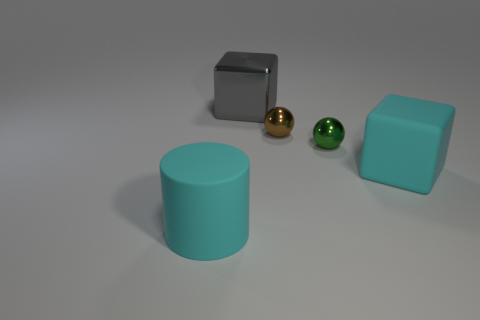What is the color of the other small thing that is the same shape as the brown shiny object?
Offer a terse response. Green. Are there any other things that have the same shape as the tiny green thing?
Give a very brief answer. Yes. Is the number of brown metal things in front of the small brown thing the same as the number of large brown balls?
Give a very brief answer. Yes. There is a green metallic sphere; are there any large gray cubes in front of it?
Make the answer very short. No. There is a rubber thing behind the cyan matte object left of the block behind the brown sphere; what size is it?
Your response must be concise. Large. Does the cyan matte thing that is to the left of the brown metal sphere have the same shape as the tiny green shiny thing on the right side of the big cyan cylinder?
Offer a terse response. No. What is the size of the other metal thing that is the same shape as the small brown thing?
Provide a short and direct response. Small. How many tiny brown objects are made of the same material as the small brown ball?
Ensure brevity in your answer.  0. What is the cylinder made of?
Your answer should be compact. Rubber. The big cyan thing that is right of the small object left of the small green object is what shape?
Keep it short and to the point. Cube. 